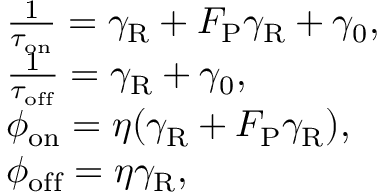Convert formula to latex. <formula><loc_0><loc_0><loc_500><loc_500>\begin{array} { r l } & { \quad \frac { 1 } { \tau _ { o n } } = \gamma _ { R } + F _ { P } \gamma _ { R } + \gamma _ { 0 } , } \\ & { \quad \frac { 1 } { \tau _ { o f f } } = \gamma _ { R } + \gamma _ { 0 } , } \\ & { \quad \phi _ { o n } = \eta ( \gamma _ { R } + F _ { P } \gamma _ { R } ) , } \\ & { \quad \phi _ { o f f } = \eta \gamma _ { R } , } \end{array}</formula> 